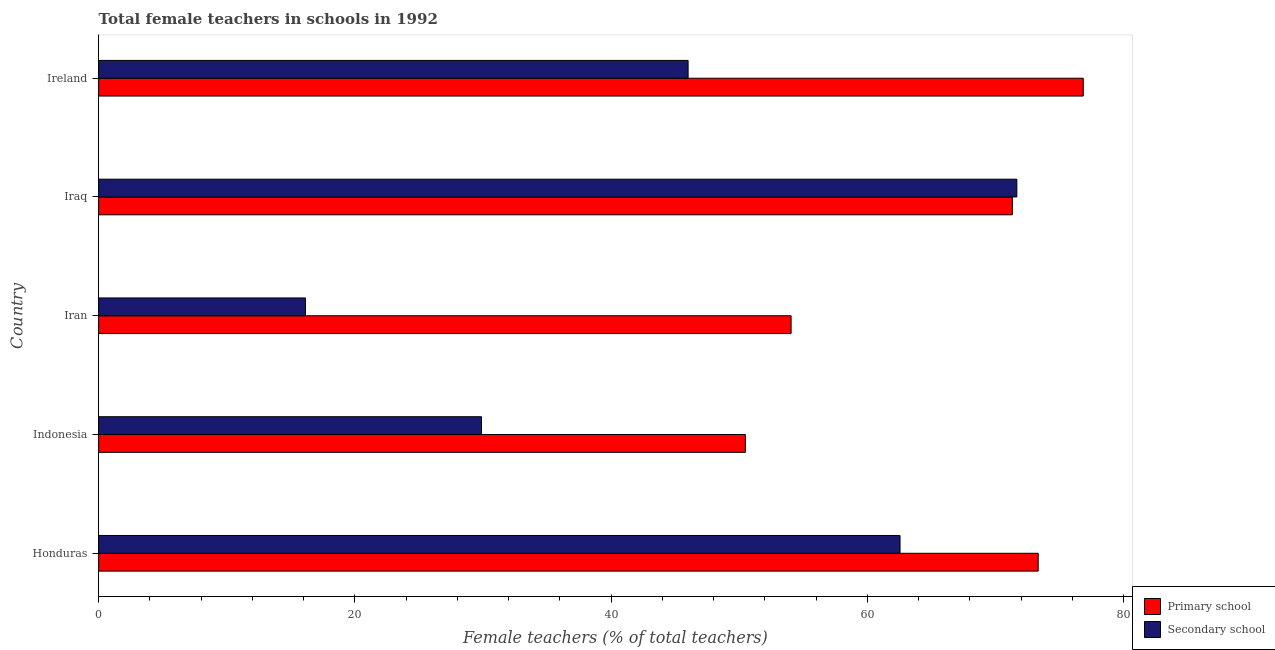How many groups of bars are there?
Give a very brief answer. 5. What is the label of the 5th group of bars from the top?
Your answer should be compact. Honduras. In how many cases, is the number of bars for a given country not equal to the number of legend labels?
Provide a succinct answer. 0. What is the percentage of female teachers in secondary schools in Iran?
Offer a terse response. 16.14. Across all countries, what is the maximum percentage of female teachers in secondary schools?
Keep it short and to the point. 71.67. Across all countries, what is the minimum percentage of female teachers in primary schools?
Your answer should be compact. 50.48. In which country was the percentage of female teachers in secondary schools maximum?
Give a very brief answer. Iraq. In which country was the percentage of female teachers in secondary schools minimum?
Provide a short and direct response. Iran. What is the total percentage of female teachers in primary schools in the graph?
Make the answer very short. 326.05. What is the difference between the percentage of female teachers in primary schools in Iran and that in Ireland?
Ensure brevity in your answer.  -22.8. What is the difference between the percentage of female teachers in secondary schools in Honduras and the percentage of female teachers in primary schools in Ireland?
Ensure brevity in your answer.  -14.3. What is the average percentage of female teachers in secondary schools per country?
Your response must be concise. 45.25. What is the difference between the percentage of female teachers in primary schools and percentage of female teachers in secondary schools in Iraq?
Your response must be concise. -0.35. What is the ratio of the percentage of female teachers in secondary schools in Honduras to that in Iran?
Offer a terse response. 3.88. Is the percentage of female teachers in primary schools in Honduras less than that in Iraq?
Give a very brief answer. No. What is the difference between the highest and the second highest percentage of female teachers in secondary schools?
Provide a short and direct response. 9.12. What is the difference between the highest and the lowest percentage of female teachers in primary schools?
Offer a terse response. 26.38. What does the 2nd bar from the top in Ireland represents?
Give a very brief answer. Primary school. What does the 1st bar from the bottom in Ireland represents?
Your answer should be compact. Primary school. How many bars are there?
Provide a short and direct response. 10. Are all the bars in the graph horizontal?
Offer a terse response. Yes. How many countries are there in the graph?
Your answer should be compact. 5. Are the values on the major ticks of X-axis written in scientific E-notation?
Offer a very short reply. No. Where does the legend appear in the graph?
Keep it short and to the point. Bottom right. How are the legend labels stacked?
Make the answer very short. Vertical. What is the title of the graph?
Your answer should be very brief. Total female teachers in schools in 1992. Does "Measles" appear as one of the legend labels in the graph?
Your response must be concise. No. What is the label or title of the X-axis?
Your answer should be compact. Female teachers (% of total teachers). What is the label or title of the Y-axis?
Your answer should be very brief. Country. What is the Female teachers (% of total teachers) of Primary school in Honduras?
Make the answer very short. 73.34. What is the Female teachers (% of total teachers) of Secondary school in Honduras?
Make the answer very short. 62.55. What is the Female teachers (% of total teachers) of Primary school in Indonesia?
Provide a succinct answer. 50.48. What is the Female teachers (% of total teachers) in Secondary school in Indonesia?
Provide a short and direct response. 29.88. What is the Female teachers (% of total teachers) of Primary school in Iran?
Provide a succinct answer. 54.05. What is the Female teachers (% of total teachers) in Secondary school in Iran?
Give a very brief answer. 16.14. What is the Female teachers (% of total teachers) of Primary school in Iraq?
Your answer should be compact. 71.32. What is the Female teachers (% of total teachers) of Secondary school in Iraq?
Offer a very short reply. 71.67. What is the Female teachers (% of total teachers) in Primary school in Ireland?
Provide a succinct answer. 76.86. What is the Female teachers (% of total teachers) in Secondary school in Ireland?
Your answer should be very brief. 46.01. Across all countries, what is the maximum Female teachers (% of total teachers) of Primary school?
Provide a short and direct response. 76.86. Across all countries, what is the maximum Female teachers (% of total teachers) of Secondary school?
Your response must be concise. 71.67. Across all countries, what is the minimum Female teachers (% of total teachers) of Primary school?
Your response must be concise. 50.48. Across all countries, what is the minimum Female teachers (% of total teachers) in Secondary school?
Give a very brief answer. 16.14. What is the total Female teachers (% of total teachers) in Primary school in the graph?
Give a very brief answer. 326.05. What is the total Female teachers (% of total teachers) of Secondary school in the graph?
Ensure brevity in your answer.  226.26. What is the difference between the Female teachers (% of total teachers) in Primary school in Honduras and that in Indonesia?
Your answer should be very brief. 22.86. What is the difference between the Female teachers (% of total teachers) in Secondary school in Honduras and that in Indonesia?
Keep it short and to the point. 32.67. What is the difference between the Female teachers (% of total teachers) of Primary school in Honduras and that in Iran?
Keep it short and to the point. 19.29. What is the difference between the Female teachers (% of total teachers) in Secondary school in Honduras and that in Iran?
Your response must be concise. 46.41. What is the difference between the Female teachers (% of total teachers) of Primary school in Honduras and that in Iraq?
Ensure brevity in your answer.  2.02. What is the difference between the Female teachers (% of total teachers) of Secondary school in Honduras and that in Iraq?
Give a very brief answer. -9.12. What is the difference between the Female teachers (% of total teachers) of Primary school in Honduras and that in Ireland?
Provide a short and direct response. -3.52. What is the difference between the Female teachers (% of total teachers) in Secondary school in Honduras and that in Ireland?
Offer a terse response. 16.54. What is the difference between the Female teachers (% of total teachers) of Primary school in Indonesia and that in Iran?
Offer a terse response. -3.57. What is the difference between the Female teachers (% of total teachers) in Secondary school in Indonesia and that in Iran?
Give a very brief answer. 13.74. What is the difference between the Female teachers (% of total teachers) in Primary school in Indonesia and that in Iraq?
Give a very brief answer. -20.84. What is the difference between the Female teachers (% of total teachers) of Secondary school in Indonesia and that in Iraq?
Ensure brevity in your answer.  -41.79. What is the difference between the Female teachers (% of total teachers) in Primary school in Indonesia and that in Ireland?
Your answer should be compact. -26.38. What is the difference between the Female teachers (% of total teachers) in Secondary school in Indonesia and that in Ireland?
Your answer should be compact. -16.13. What is the difference between the Female teachers (% of total teachers) of Primary school in Iran and that in Iraq?
Ensure brevity in your answer.  -17.27. What is the difference between the Female teachers (% of total teachers) in Secondary school in Iran and that in Iraq?
Provide a short and direct response. -55.53. What is the difference between the Female teachers (% of total teachers) in Primary school in Iran and that in Ireland?
Offer a very short reply. -22.8. What is the difference between the Female teachers (% of total teachers) in Secondary school in Iran and that in Ireland?
Give a very brief answer. -29.87. What is the difference between the Female teachers (% of total teachers) of Primary school in Iraq and that in Ireland?
Give a very brief answer. -5.54. What is the difference between the Female teachers (% of total teachers) of Secondary school in Iraq and that in Ireland?
Ensure brevity in your answer.  25.66. What is the difference between the Female teachers (% of total teachers) in Primary school in Honduras and the Female teachers (% of total teachers) in Secondary school in Indonesia?
Offer a very short reply. 43.46. What is the difference between the Female teachers (% of total teachers) of Primary school in Honduras and the Female teachers (% of total teachers) of Secondary school in Iran?
Provide a short and direct response. 57.2. What is the difference between the Female teachers (% of total teachers) in Primary school in Honduras and the Female teachers (% of total teachers) in Secondary school in Iraq?
Make the answer very short. 1.67. What is the difference between the Female teachers (% of total teachers) of Primary school in Honduras and the Female teachers (% of total teachers) of Secondary school in Ireland?
Offer a very short reply. 27.33. What is the difference between the Female teachers (% of total teachers) in Primary school in Indonesia and the Female teachers (% of total teachers) in Secondary school in Iran?
Your answer should be very brief. 34.34. What is the difference between the Female teachers (% of total teachers) of Primary school in Indonesia and the Female teachers (% of total teachers) of Secondary school in Iraq?
Ensure brevity in your answer.  -21.19. What is the difference between the Female teachers (% of total teachers) in Primary school in Indonesia and the Female teachers (% of total teachers) in Secondary school in Ireland?
Your answer should be very brief. 4.47. What is the difference between the Female teachers (% of total teachers) in Primary school in Iran and the Female teachers (% of total teachers) in Secondary school in Iraq?
Offer a very short reply. -17.62. What is the difference between the Female teachers (% of total teachers) of Primary school in Iran and the Female teachers (% of total teachers) of Secondary school in Ireland?
Offer a very short reply. 8.04. What is the difference between the Female teachers (% of total teachers) of Primary school in Iraq and the Female teachers (% of total teachers) of Secondary school in Ireland?
Your answer should be very brief. 25.31. What is the average Female teachers (% of total teachers) of Primary school per country?
Provide a succinct answer. 65.21. What is the average Female teachers (% of total teachers) in Secondary school per country?
Give a very brief answer. 45.25. What is the difference between the Female teachers (% of total teachers) of Primary school and Female teachers (% of total teachers) of Secondary school in Honduras?
Ensure brevity in your answer.  10.78. What is the difference between the Female teachers (% of total teachers) in Primary school and Female teachers (% of total teachers) in Secondary school in Indonesia?
Keep it short and to the point. 20.6. What is the difference between the Female teachers (% of total teachers) in Primary school and Female teachers (% of total teachers) in Secondary school in Iran?
Provide a succinct answer. 37.91. What is the difference between the Female teachers (% of total teachers) in Primary school and Female teachers (% of total teachers) in Secondary school in Iraq?
Keep it short and to the point. -0.35. What is the difference between the Female teachers (% of total teachers) in Primary school and Female teachers (% of total teachers) in Secondary school in Ireland?
Your answer should be compact. 30.84. What is the ratio of the Female teachers (% of total teachers) of Primary school in Honduras to that in Indonesia?
Your answer should be very brief. 1.45. What is the ratio of the Female teachers (% of total teachers) of Secondary school in Honduras to that in Indonesia?
Offer a very short reply. 2.09. What is the ratio of the Female teachers (% of total teachers) of Primary school in Honduras to that in Iran?
Your response must be concise. 1.36. What is the ratio of the Female teachers (% of total teachers) in Secondary school in Honduras to that in Iran?
Make the answer very short. 3.88. What is the ratio of the Female teachers (% of total teachers) of Primary school in Honduras to that in Iraq?
Keep it short and to the point. 1.03. What is the ratio of the Female teachers (% of total teachers) of Secondary school in Honduras to that in Iraq?
Offer a very short reply. 0.87. What is the ratio of the Female teachers (% of total teachers) in Primary school in Honduras to that in Ireland?
Ensure brevity in your answer.  0.95. What is the ratio of the Female teachers (% of total teachers) of Secondary school in Honduras to that in Ireland?
Your response must be concise. 1.36. What is the ratio of the Female teachers (% of total teachers) in Primary school in Indonesia to that in Iran?
Provide a succinct answer. 0.93. What is the ratio of the Female teachers (% of total teachers) in Secondary school in Indonesia to that in Iran?
Offer a very short reply. 1.85. What is the ratio of the Female teachers (% of total teachers) of Primary school in Indonesia to that in Iraq?
Your answer should be very brief. 0.71. What is the ratio of the Female teachers (% of total teachers) in Secondary school in Indonesia to that in Iraq?
Give a very brief answer. 0.42. What is the ratio of the Female teachers (% of total teachers) in Primary school in Indonesia to that in Ireland?
Offer a terse response. 0.66. What is the ratio of the Female teachers (% of total teachers) in Secondary school in Indonesia to that in Ireland?
Make the answer very short. 0.65. What is the ratio of the Female teachers (% of total teachers) in Primary school in Iran to that in Iraq?
Give a very brief answer. 0.76. What is the ratio of the Female teachers (% of total teachers) in Secondary school in Iran to that in Iraq?
Your answer should be compact. 0.23. What is the ratio of the Female teachers (% of total teachers) of Primary school in Iran to that in Ireland?
Give a very brief answer. 0.7. What is the ratio of the Female teachers (% of total teachers) in Secondary school in Iran to that in Ireland?
Give a very brief answer. 0.35. What is the ratio of the Female teachers (% of total teachers) of Primary school in Iraq to that in Ireland?
Keep it short and to the point. 0.93. What is the ratio of the Female teachers (% of total teachers) in Secondary school in Iraq to that in Ireland?
Provide a succinct answer. 1.56. What is the difference between the highest and the second highest Female teachers (% of total teachers) in Primary school?
Offer a very short reply. 3.52. What is the difference between the highest and the second highest Female teachers (% of total teachers) in Secondary school?
Your answer should be very brief. 9.12. What is the difference between the highest and the lowest Female teachers (% of total teachers) in Primary school?
Offer a very short reply. 26.38. What is the difference between the highest and the lowest Female teachers (% of total teachers) of Secondary school?
Keep it short and to the point. 55.53. 